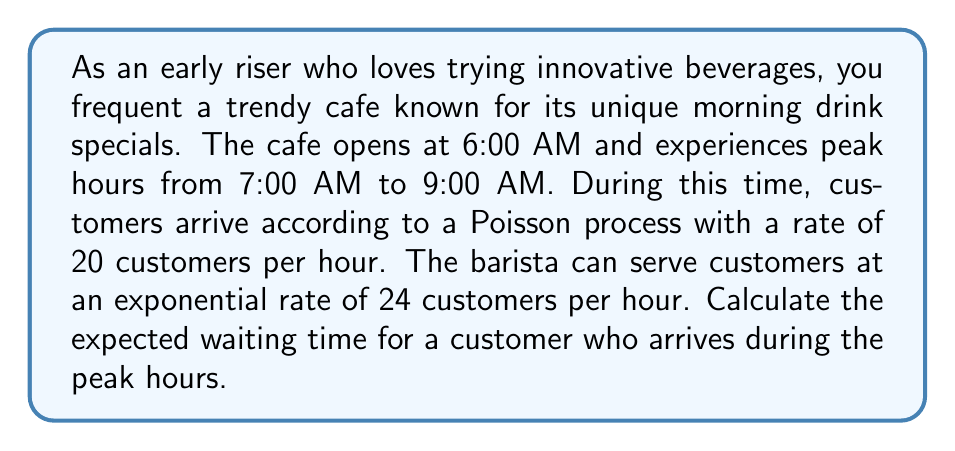Provide a solution to this math problem. To solve this problem, we'll use the M/M/1 queueing model, where arrivals follow a Poisson process and service times are exponentially distributed.

Step 1: Identify the arrival rate (λ) and service rate (μ)
λ = 20 customers/hour
μ = 24 customers/hour

Step 2: Calculate the utilization factor (ρ)
$$\rho = \frac{\lambda}{\mu} = \frac{20}{24} = \frac{5}{6} \approx 0.833$$

Step 3: Calculate the expected number of customers in the system (L)
$$L = \frac{\rho}{1-\rho} = \frac{5/6}{1-5/6} = 5$$

Step 4: Calculate the expected waiting time in the system (W) using Little's Law
$$W = \frac{L}{\lambda} = \frac{5}{20} = 0.25 \text{ hours}$$

Step 5: Convert the waiting time to minutes
$$0.25 \text{ hours} \times 60 \text{ minutes/hour} = 15 \text{ minutes}$$

Therefore, the expected waiting time for a customer arriving during peak hours is 15 minutes.
Answer: 15 minutes 